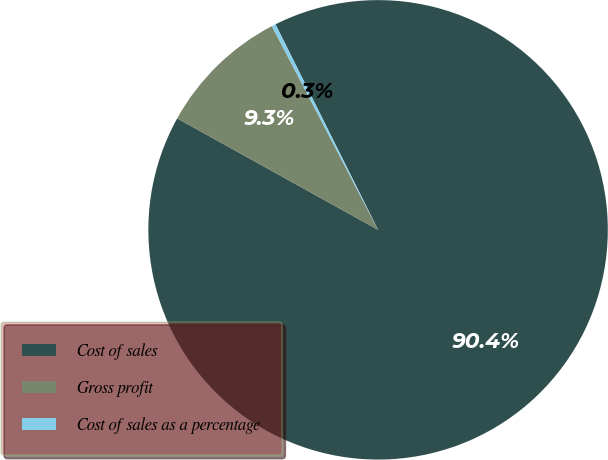<chart> <loc_0><loc_0><loc_500><loc_500><pie_chart><fcel>Cost of sales<fcel>Gross profit<fcel>Cost of sales as a percentage<nl><fcel>90.42%<fcel>9.29%<fcel>0.28%<nl></chart> 